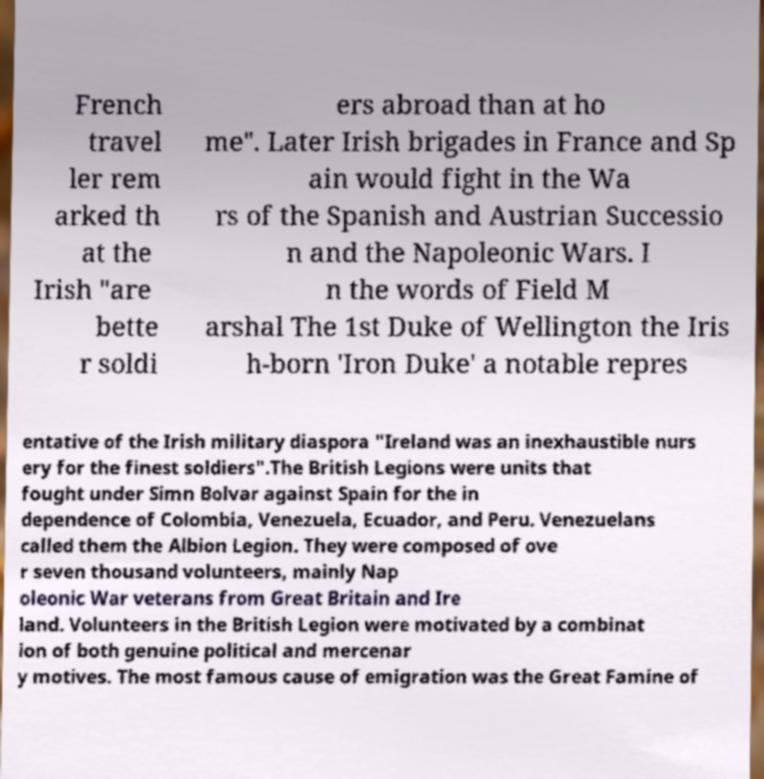Please read and relay the text visible in this image. What does it say? French travel ler rem arked th at the Irish "are bette r soldi ers abroad than at ho me". Later Irish brigades in France and Sp ain would fight in the Wa rs of the Spanish and Austrian Successio n and the Napoleonic Wars. I n the words of Field M arshal The 1st Duke of Wellington the Iris h-born 'Iron Duke' a notable repres entative of the Irish military diaspora "Ireland was an inexhaustible nurs ery for the finest soldiers".The British Legions were units that fought under Simn Bolvar against Spain for the in dependence of Colombia, Venezuela, Ecuador, and Peru. Venezuelans called them the Albion Legion. They were composed of ove r seven thousand volunteers, mainly Nap oleonic War veterans from Great Britain and Ire land. Volunteers in the British Legion were motivated by a combinat ion of both genuine political and mercenar y motives. The most famous cause of emigration was the Great Famine of 